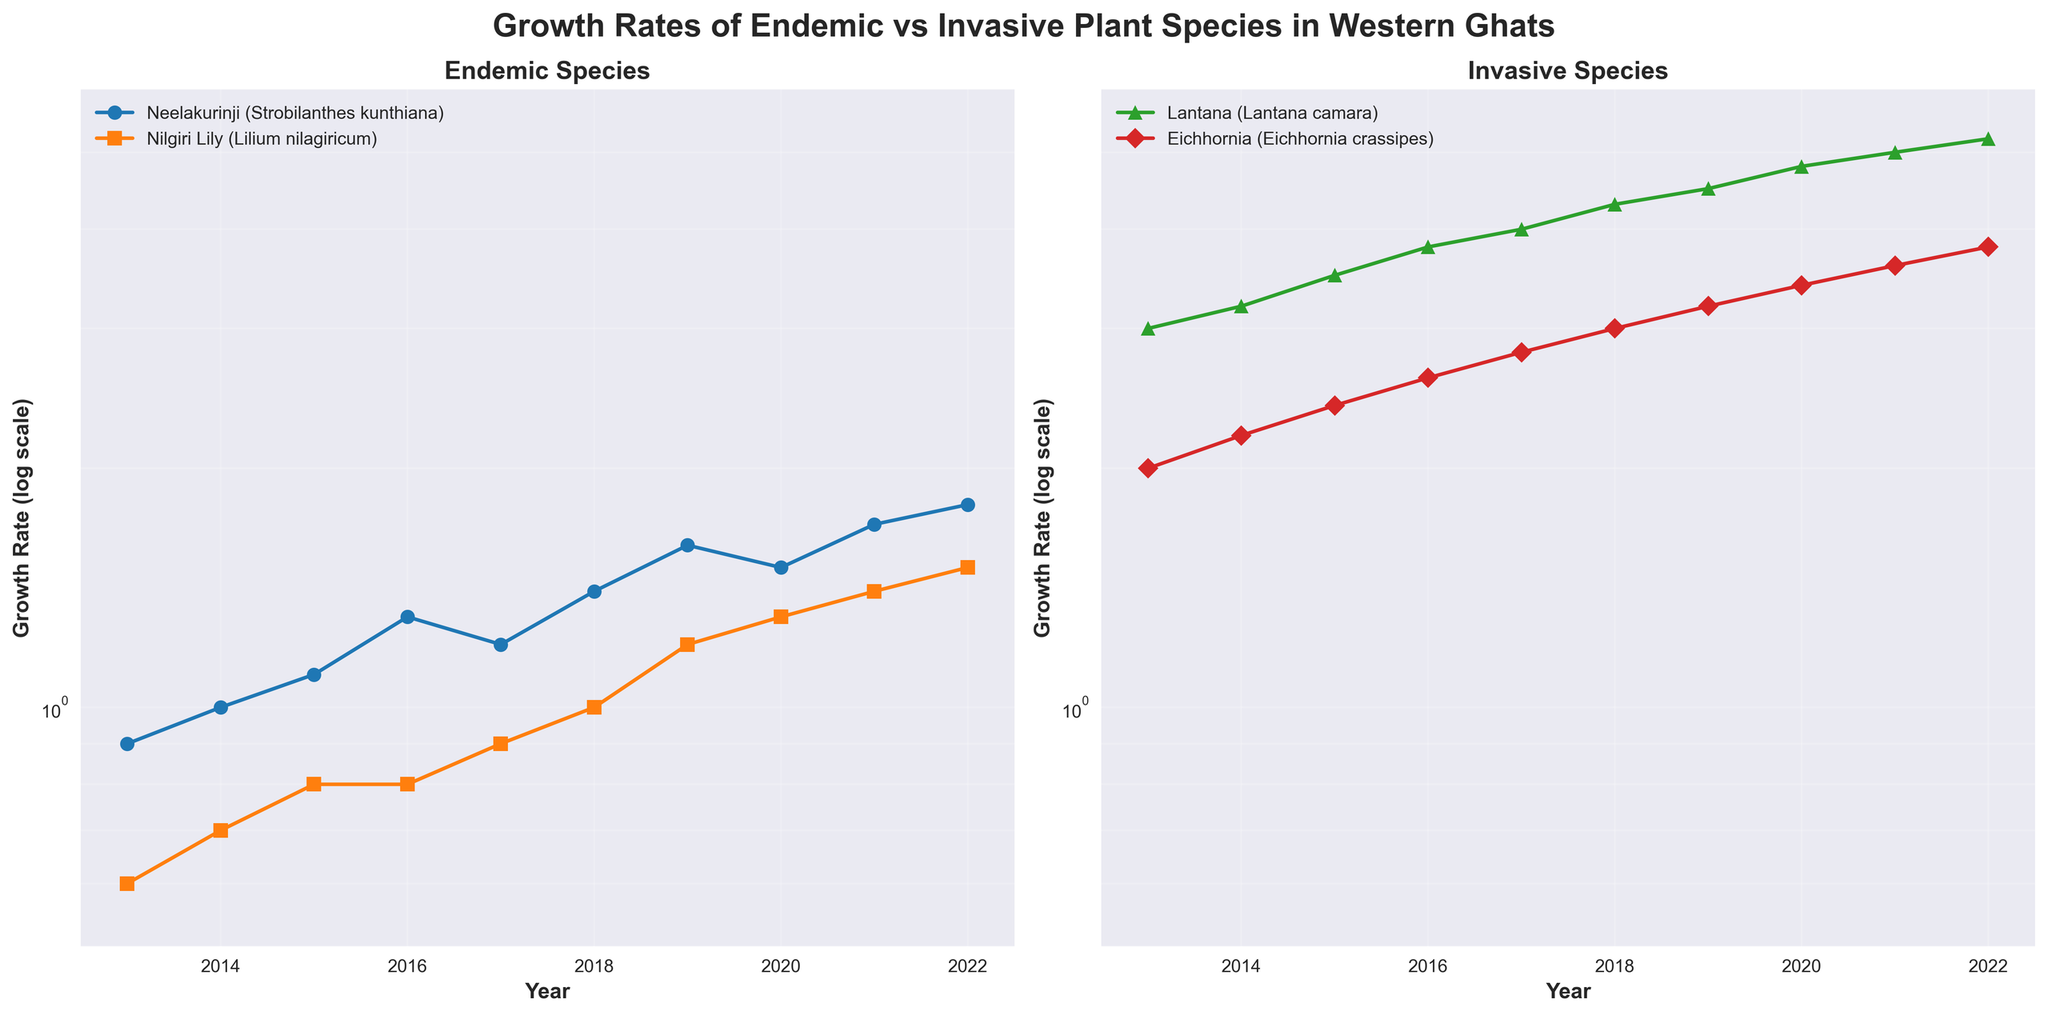Which species show the highest growth rate in 2022? Refer to the right subplot for invasive species and the left subplot for endemic species. Neelakurinji (Strobilanthes kunthiana) shows a growth rate of 1.8, Nilgiri Lily (Lilium nilagiricum) shows 1.5, Lantana (Lantana camara) shows 5.2, and Eichhornia (Eichhornia crassipes) shows 3.8. The highest growth rate among them is for Lantana (Lantana camara).
Answer: Lantana (Lantana camara) Which species shows the lowest growth rate in 2022? Refer to both subplots for the year 2022. Neelakurinji (Strobilanthes kunthiana) shows a growth rate of 1.8, Nilgiri Lily (Lilium nilagiricum) shows 1.5, Lantana (Lantana camara) shows 5.2, and Eichhornia (Eichhornia crassipes) shows 3.8. The lowest growth rate is for Nilgiri Lily (Lilium nilagiricum).
Answer: Nilgiri Lily (Lilium nilagiricum) How does the growth rate of Lantana (Lantana camara) in 2016 compare to that of Neelakurinji (Strobilanthes kunthiana) in the same year? Look at 2016 data points in both subplots. Lantana (Lantana camara) has a growth rate of 3.8, while Neelakurinji (Strobilanthes kunthiana) has a growth rate of 1.3. Lantana's growth rate is higher.
Answer: Lantana's growth rate is higher Between 2013 and 2022, which endemic species had a more significant growth rate increase? Look at the growth rate of Neelakurinji (Strobilanthes kunthiana) and Nilgiri Lily (Lilium nilagiricum) from 2013 to 2022 in the left subplot. Neelakurinji’s growth rate increased from 0.9 to 1.8 (increase of 0.9) and Nilgiri Lily’s growth rate increased from 0.6 to 1.5 (increase of 0.9). Both had the same increase.
Answer: Both had the same increase What is the overall trend in growth rates for invasive species from 2013 to 2022? Look at the right subplot for the invasive species. Both Lantana (Lantana camara) and Eichhornia (Eichhornia crassipes) show a generally increasing trend in growth rates from 2013 to 2022.
Answer: Generally increasing What is the average growth rate of Neelakurinji (Strobilanthes kunthiana) from 2013 to 2022? Sum all the growth rates for Neelakurinji (Strobilanthes kunthiana) from 2013 to 2022: 0.9 + 1.0 + 1.1 + 1.3 + 1.2 + 1.4 + 1.6 + 1.5 + 1.7 + 1.8 = 13.5. Divide by the number of years (10), which gives an average of 1.35.
Answer: 1.35 In which year did Eichhornia (Eichhornia crassipes) first reach a growth rate of 3.0? Look at the growth rate data points for Eichhornia (Eichhornia crassipes) in the right subplot and identify the year it reached 3.0. This happened in 2018.
Answer: 2018 Between Nilgiri Lily (Lilium nilagiricum) and Eichhornia (Eichhornia crassipes), which species had a higher growth rate in 2020? Compare the 2020 growth rates in both subplots. Nilgiri Lily (Lilium nilagiricum) has a growth rate of 1.3 and Eichhornia (Eichhornia crassipes) has a growth rate of 3.4. Eichhornia had the higher growth rate.
Answer: Eichhornia (Eichhornia crassipes) 